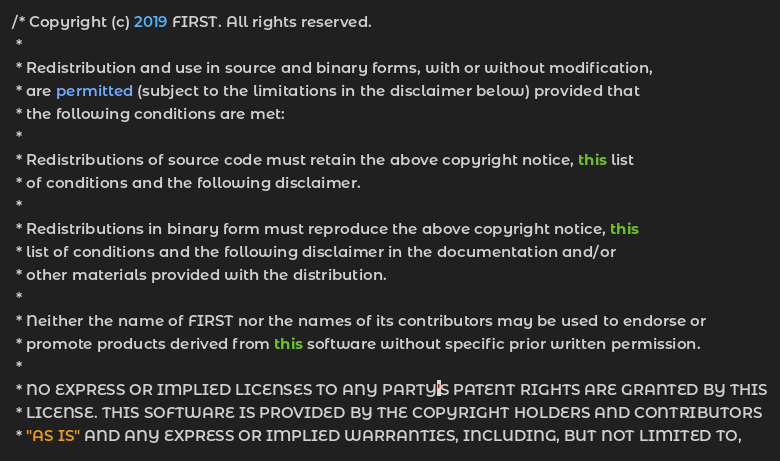Convert code to text. <code><loc_0><loc_0><loc_500><loc_500><_Java_>/* Copyright (c) 2019 FIRST. All rights reserved.
 *
 * Redistribution and use in source and binary forms, with or without modification,
 * are permitted (subject to the limitations in the disclaimer below) provided that
 * the following conditions are met:
 *
 * Redistributions of source code must retain the above copyright notice, this list
 * of conditions and the following disclaimer.
 *
 * Redistributions in binary form must reproduce the above copyright notice, this
 * list of conditions and the following disclaimer in the documentation and/or
 * other materials provided with the distribution.
 *
 * Neither the name of FIRST nor the names of its contributors may be used to endorse or
 * promote products derived from this software without specific prior written permission.
 *
 * NO EXPRESS OR IMPLIED LICENSES TO ANY PARTY'S PATENT RIGHTS ARE GRANTED BY THIS
 * LICENSE. THIS SOFTWARE IS PROVIDED BY THE COPYRIGHT HOLDERS AND CONTRIBUTORS
 * "AS IS" AND ANY EXPRESS OR IMPLIED WARRANTIES, INCLUDING, BUT NOT LIMITED TO,</code> 